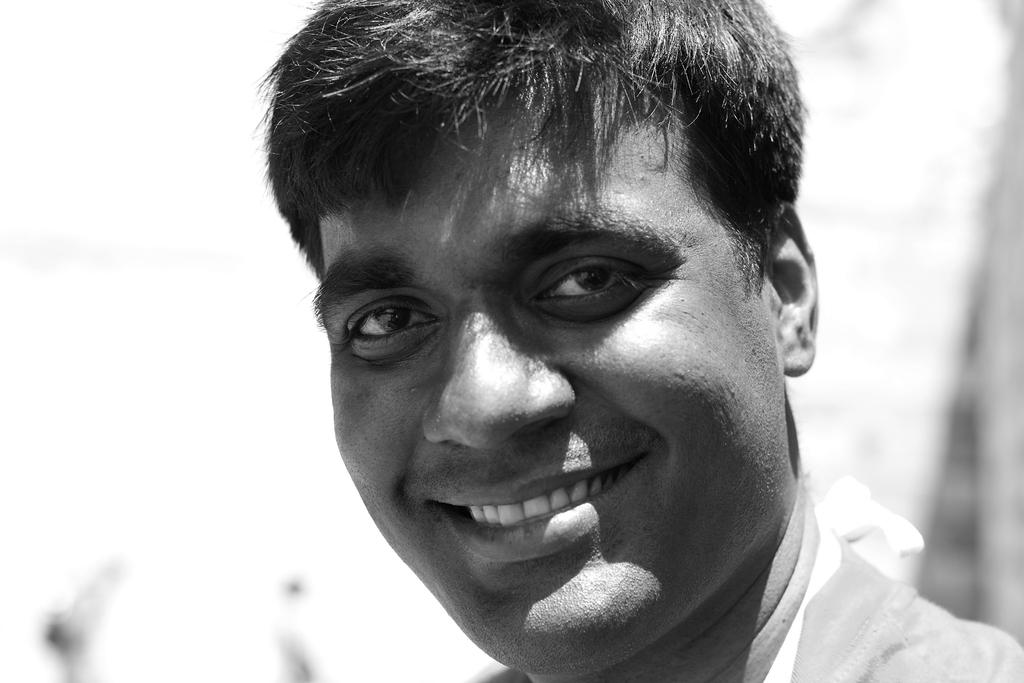What is the color scheme of the image? The image is black and white. Can you describe the person in the image? There is a person in the image, and they are smiling. What can be said about the background of the image? The background of the image is blurry. What type of horn is the person holding in the image? There is no horn present in the image; it is a black and white image of a person smiling with a blurry background. 